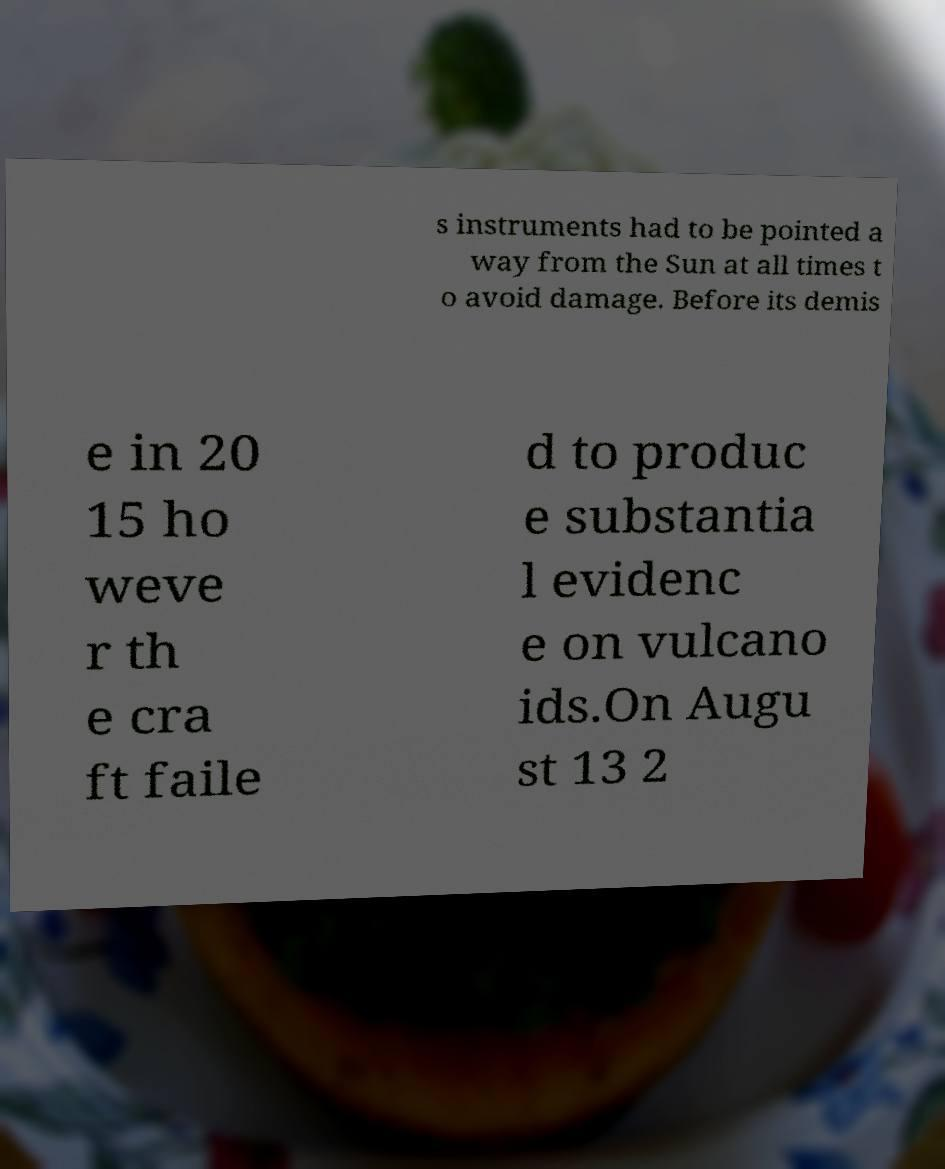What messages or text are displayed in this image? I need them in a readable, typed format. s instruments had to be pointed a way from the Sun at all times t o avoid damage. Before its demis e in 20 15 ho weve r th e cra ft faile d to produc e substantia l evidenc e on vulcano ids.On Augu st 13 2 